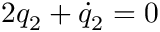<formula> <loc_0><loc_0><loc_500><loc_500>2 q _ { 2 } + \dot { q } _ { 2 } = 0</formula> 